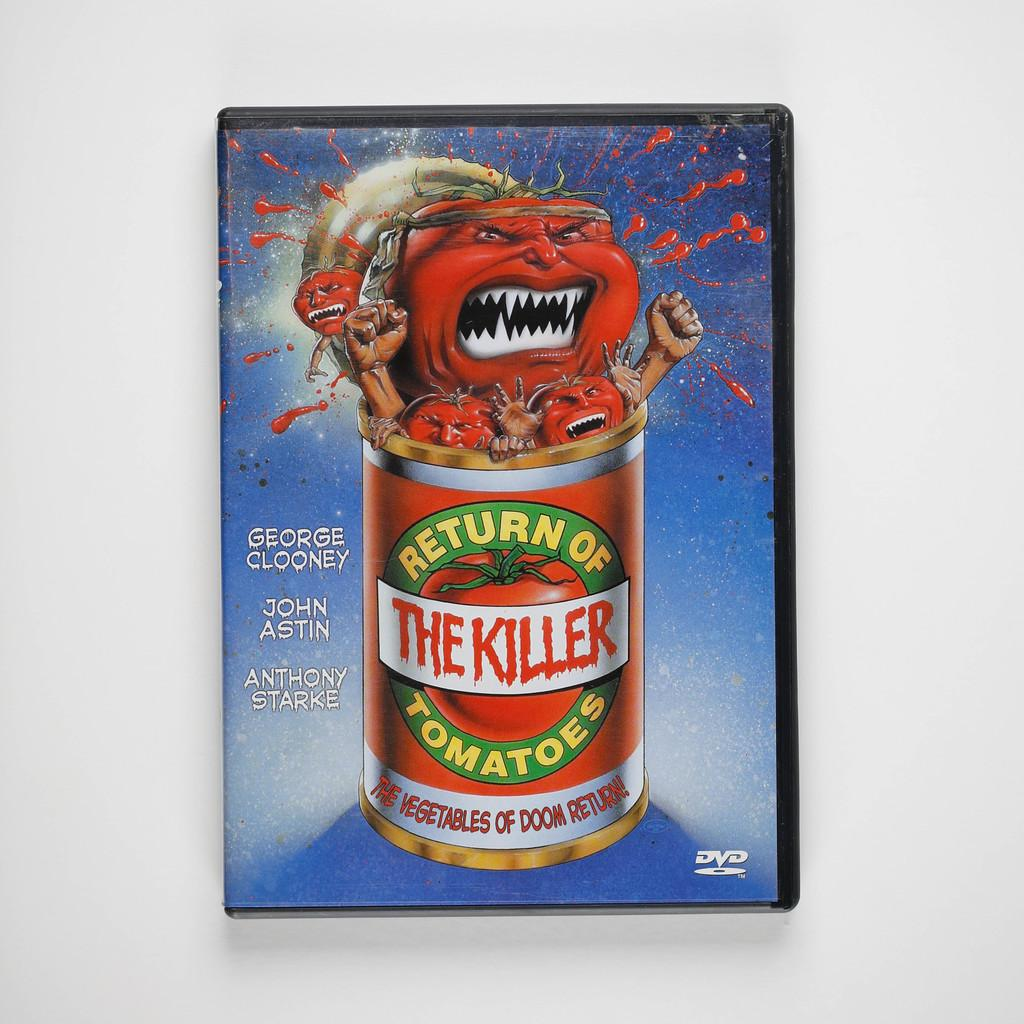What type of object is depicted in the image? The object is a DVD case. What can be seen on the DVD case? There is a picture on the DVD case, and there are letters on it as well. What is the picture of? The picture is of a tin. What is inside the tin? The tin contains tomatoes. What color is the background of the image? The background of the image appears white in color. How many faces can be seen on the DVD case in the image? There are no faces depicted on the DVD case in the image. What type of stone is used to create the DVD case? The DVD case is not made of stone; it is likely made of plastic or another material. 